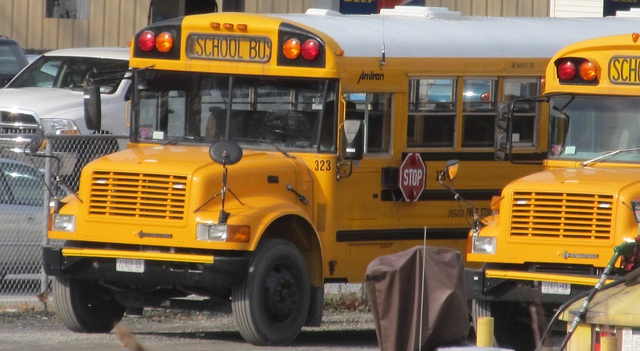Describe the objects in this image and their specific colors. I can see bus in tan, black, olive, orange, and gray tones, bus in tan, orange, black, gray, and maroon tones, truck in tan, lightgray, darkgray, gray, and black tones, car in tan and gray tones, and stop sign in tan, maroon, and gray tones in this image. 